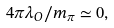Convert formula to latex. <formula><loc_0><loc_0><loc_500><loc_500>4 \pi \lambda _ { O } / m _ { \pi } \simeq 0 ,</formula> 